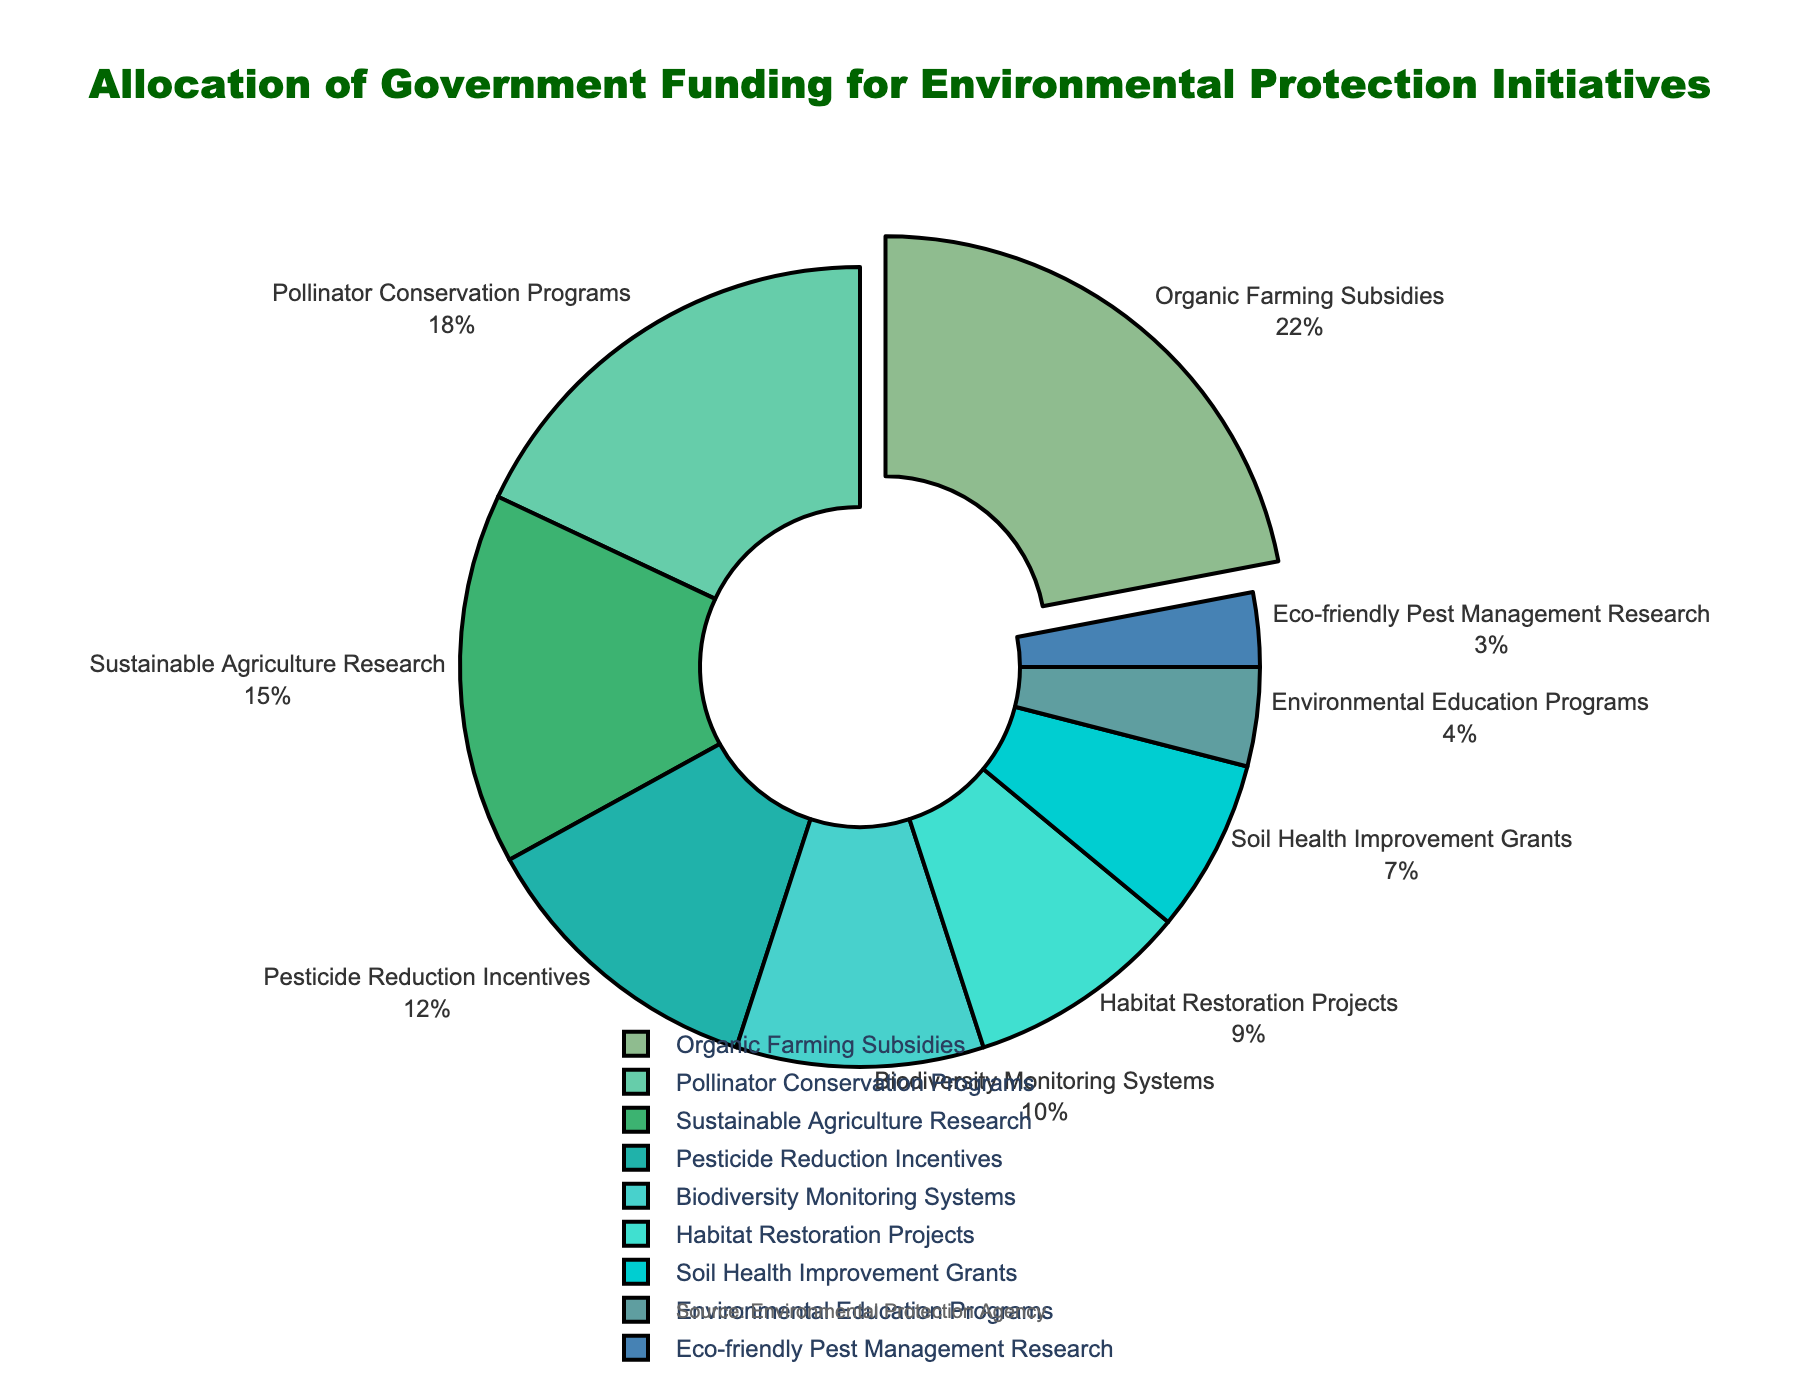What proportion of the budget is allocated to Organic Farming Subsidies and Pollinator Conservation Programs combined? Add the allocation percentages of Organic Farming Subsidies (22%) and Pollinator Conservation Programs (18%). 22 + 18 = 40
Answer: 40% Which initiative receives the least amount of funding? Look for the smallest percentage on the pie chart. Eco-friendly Pest Management Research has the smallest allocation with 3%.
Answer: Eco-friendly Pest Management Research Is the funding for Pesticide Reduction Incentives greater than or less than Biodiversity Monitoring Systems? Compare the percentages of Pesticide Reduction Incentives (12%) and Biodiversity Monitoring Systems (10%). 12% is greater than 10%.
Answer: Greater How does the allocation for Habitat Restoration Projects compare with the allocation for Soil Health Improvement Grants? Compare the given percentages for Habitat Restoration Projects (9%) and Soil Health Improvement Grants (7%). 9% is greater than 7%.
Answer: Habitat Restoration Projects receive more What is the total allocation for Habitat Restoration Projects, Soil Health Improvement Grants, and Environmental Education Programs combined? Add the percentages of Habitat Restoration Projects (9%), Soil Health Improvement Grants (7%), and Environmental Education Programs (4%). 9 + 7 + 4 = 20
Answer: 20% Which initiative receives the second-largest portion of the budget? Identify the second-largest percentage after looking at the largest percentage (Organic Farming Subsidies, 22%). The next largest is Pollinator Conservation Programs with 18%.
Answer: Pollinator Conservation Programs What fraction of the total funding is dedicated to Sustainable Agriculture Research relative to the total funding for Organic Farming Subsidies and Pollinator Conservation Programs? Sustainable Agriculture Research has 15%. The combined allocation for Organic Farming Subsidies (22%) and Pollinator Conservation Programs (18%) is 40%. The fraction is 15/40. Simplifying 15/40 gives 3/8.
Answer: 3/8 Is there more funding for Pesticide Reduction Incentives or Biodiversity Monitoring Systems? By how much? Compare the percentages: Pesticide Reduction Incentives (12%) and Biodiversity Monitoring Systems (10%). The difference is 12 - 10 = 2%.
Answer: More funding for Pesticide Reduction Incentives by 2% What percentage of the budget is allocated to initiatives related to pest management (Pesticide Reduction Incentives and Eco-friendly Pest Management Research combined)? Add the percentages for Pesticide Reduction Incentives (12%) and Eco-friendly Pest Management Research (3%). 12 + 3 = 15
Answer: 15% Which initiative's funding is the closest to 10%? Identify the initiative closest to 10%. Biodiversity Monitoring Systems is exactly 10%.
Answer: Biodiversity Monitoring Systems 